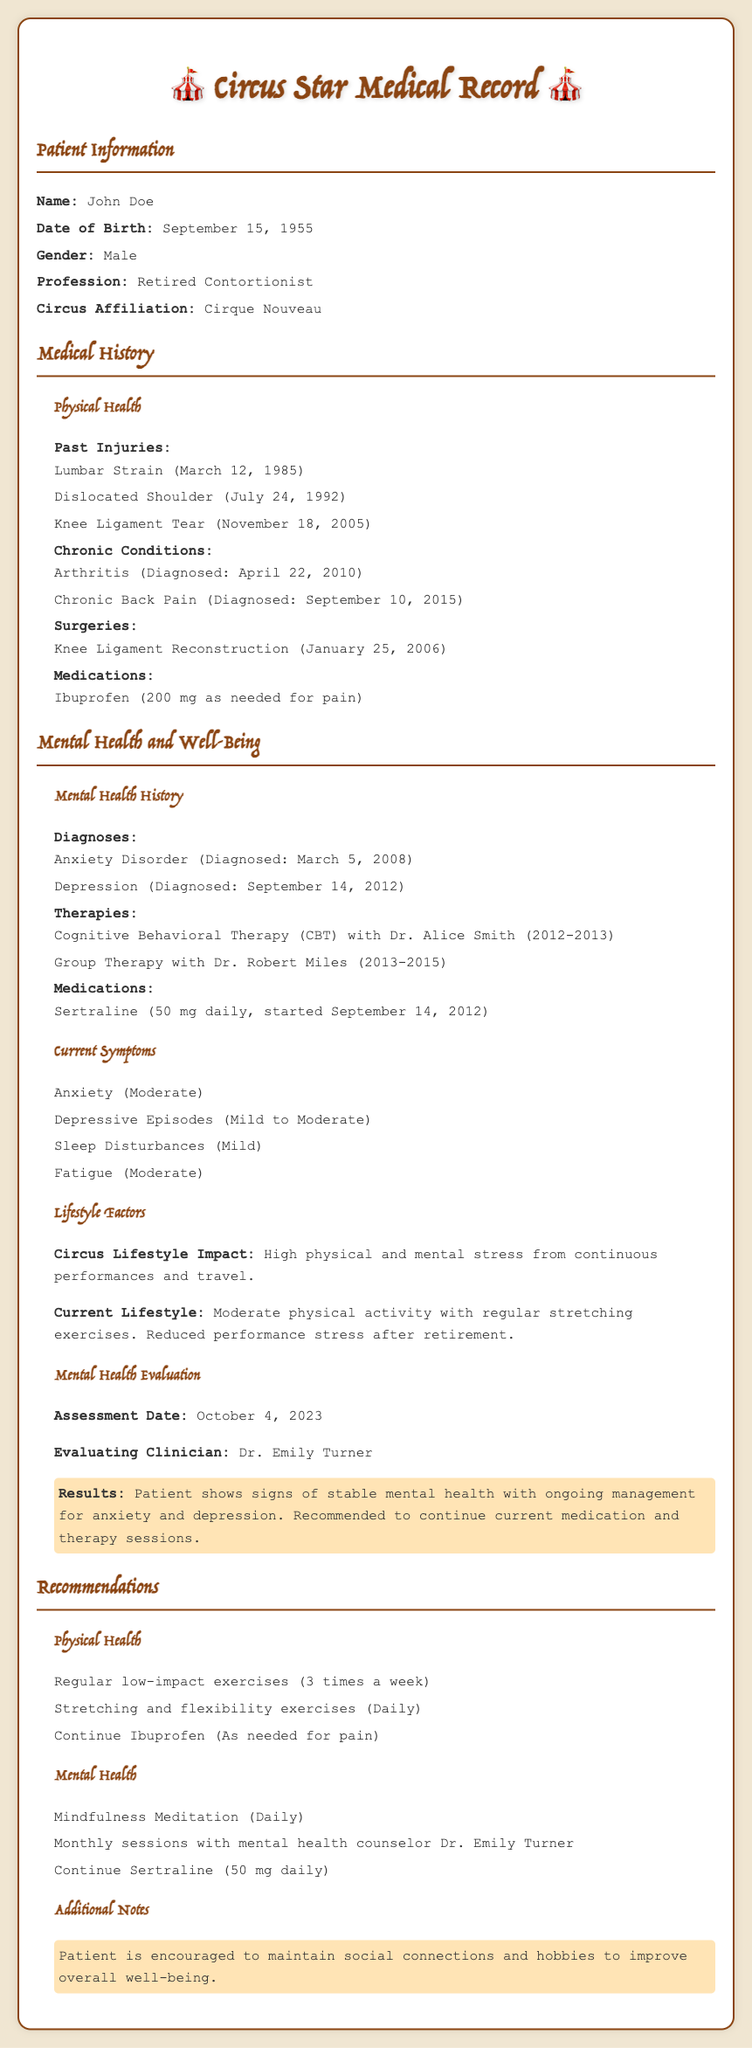What is the patient's name? The patient's name is stated in the patient information section of the document.
Answer: John Doe When was John diagnosed with Anxiety Disorder? The date of diagnosis for Anxiety Disorder is provided in the mental health history section of the document.
Answer: March 5, 2008 What medications is the patient currently taking? The medications listed in the mental health history provide specific details on what the patient is taking.
Answer: Sertraline (50 mg daily) Who conducted the mental health evaluation? This information is found under the Mental Health Evaluation section of the document.
Answer: Dr. Emily Turner What lifestyle change was noted after retirement? This change is mentioned in the lifestyle factors portion of the document.
Answer: Reduced performance stress How many past injuries does the patient have? Counting the listed past injuries in the medical history section will yield the total.
Answer: Three What type of therapy did the patient undergo from 2012 to 2013? The types of therapies the patient has received are noted in the mental health history section.
Answer: Cognitive Behavioral Therapy (CBT) What is the recommendation for mindfulness practice? This recommendation is provided in the mental health recommendations section.
Answer: Daily What is the patient's profession? The profession is specified in the patient information section.
Answer: Retired Contortionist 